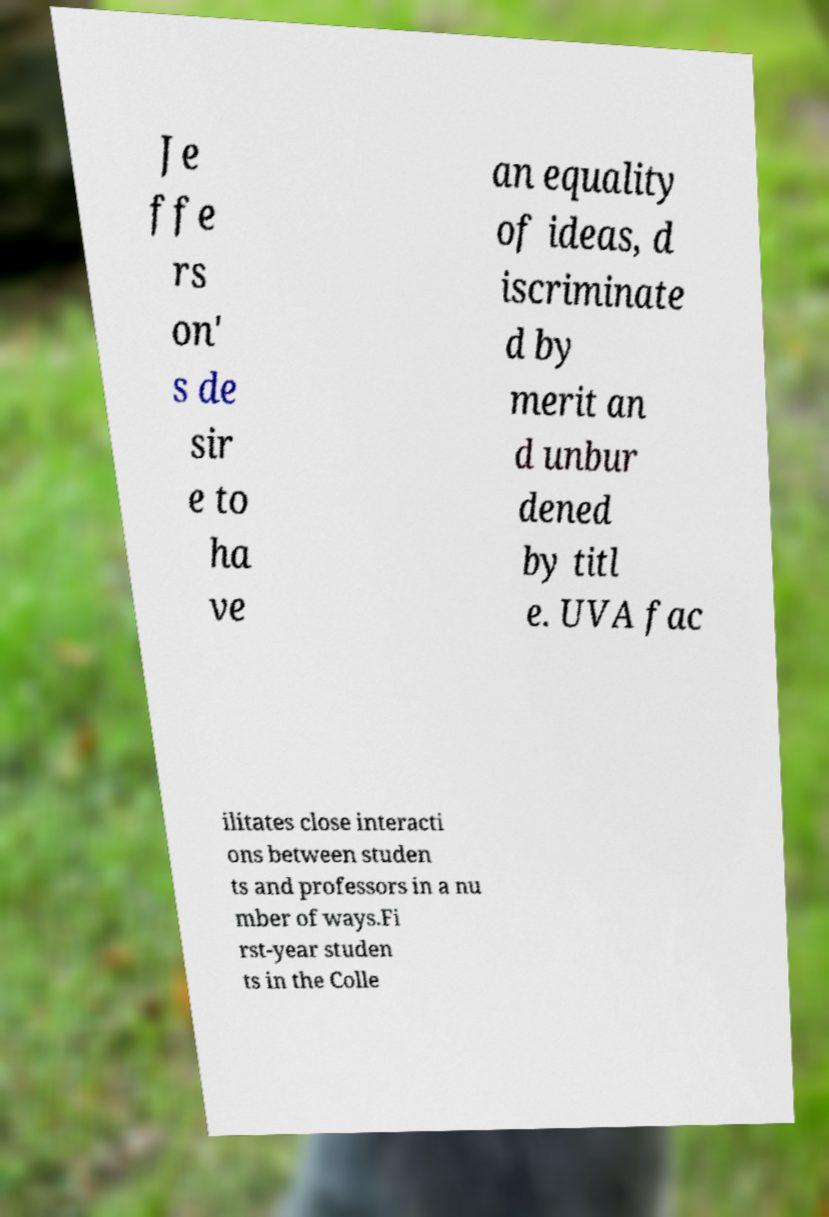There's text embedded in this image that I need extracted. Can you transcribe it verbatim? Je ffe rs on' s de sir e to ha ve an equality of ideas, d iscriminate d by merit an d unbur dened by titl e. UVA fac ilitates close interacti ons between studen ts and professors in a nu mber of ways.Fi rst-year studen ts in the Colle 